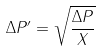<formula> <loc_0><loc_0><loc_500><loc_500>\Delta P ^ { \prime } = \sqrt { \frac { \Delta P } { X } }</formula> 